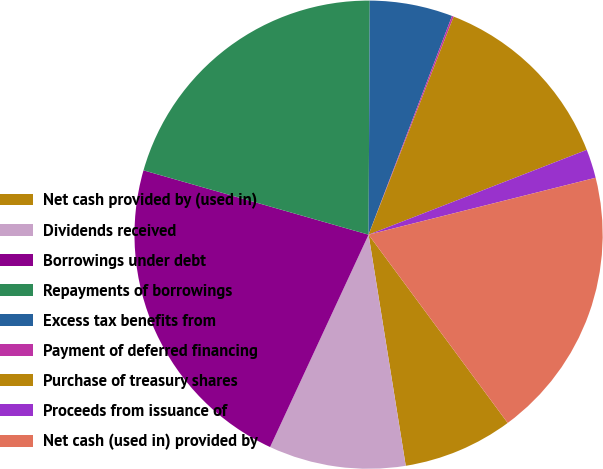Convert chart. <chart><loc_0><loc_0><loc_500><loc_500><pie_chart><fcel>Net cash provided by (used in)<fcel>Dividends received<fcel>Borrowings under debt<fcel>Repayments of borrowings<fcel>Excess tax benefits from<fcel>Payment of deferred financing<fcel>Purchase of treasury shares<fcel>Proceeds from issuance of<fcel>Net cash (used in) provided by<nl><fcel>7.59%<fcel>9.45%<fcel>22.52%<fcel>20.65%<fcel>5.72%<fcel>0.12%<fcel>13.18%<fcel>1.99%<fcel>18.78%<nl></chart> 